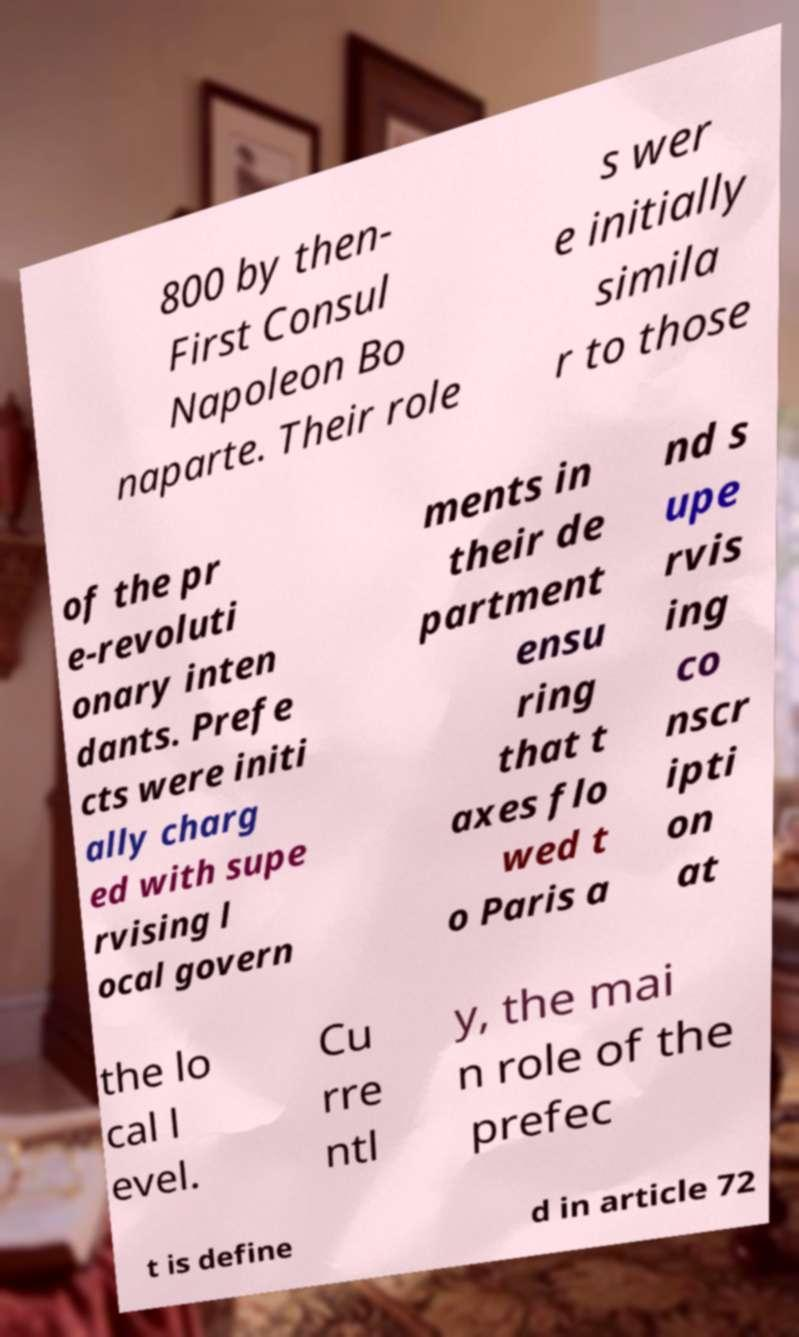I need the written content from this picture converted into text. Can you do that? 800 by then- First Consul Napoleon Bo naparte. Their role s wer e initially simila r to those of the pr e-revoluti onary inten dants. Prefe cts were initi ally charg ed with supe rvising l ocal govern ments in their de partment ensu ring that t axes flo wed t o Paris a nd s upe rvis ing co nscr ipti on at the lo cal l evel. Cu rre ntl y, the mai n role of the prefec t is define d in article 72 